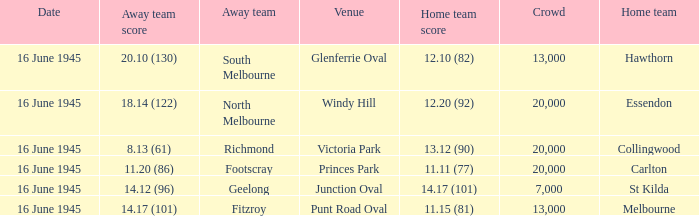In the game featuring south melbourne, what was the score for the home team? 12.10 (82). 